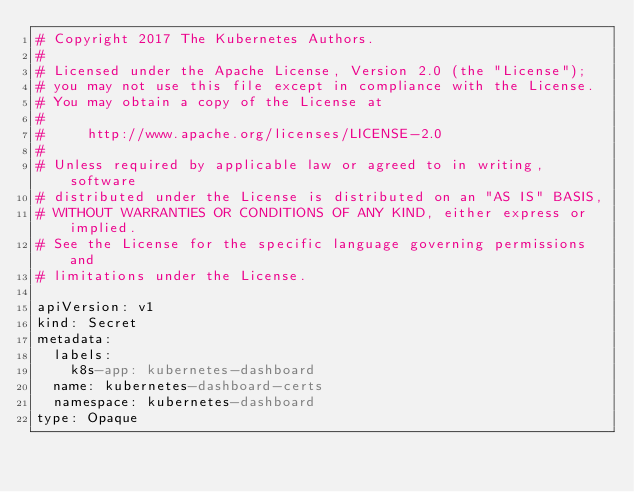<code> <loc_0><loc_0><loc_500><loc_500><_YAML_># Copyright 2017 The Kubernetes Authors.
#
# Licensed under the Apache License, Version 2.0 (the "License");
# you may not use this file except in compliance with the License.
# You may obtain a copy of the License at
#
#     http://www.apache.org/licenses/LICENSE-2.0
#
# Unless required by applicable law or agreed to in writing, software
# distributed under the License is distributed on an "AS IS" BASIS,
# WITHOUT WARRANTIES OR CONDITIONS OF ANY KIND, either express or implied.
# See the License for the specific language governing permissions and
# limitations under the License.

apiVersion: v1
kind: Secret
metadata:
  labels:
    k8s-app: kubernetes-dashboard
  name: kubernetes-dashboard-certs
  namespace: kubernetes-dashboard
type: Opaque
</code> 